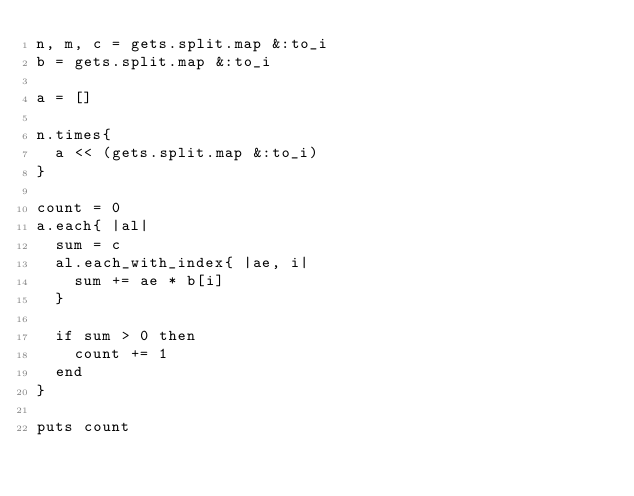<code> <loc_0><loc_0><loc_500><loc_500><_Ruby_>n, m, c = gets.split.map &:to_i
b = gets.split.map &:to_i

a = []

n.times{
	a << (gets.split.map &:to_i)
}

count = 0
a.each{ |al|
	sum = c
	al.each_with_index{ |ae, i|
		sum += ae * b[i]
	}
	
	if sum > 0 then
		count += 1
	end
}

puts count
</code> 